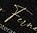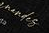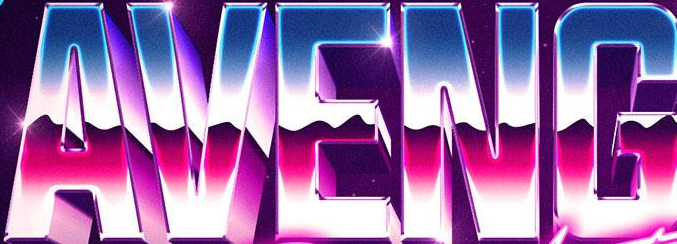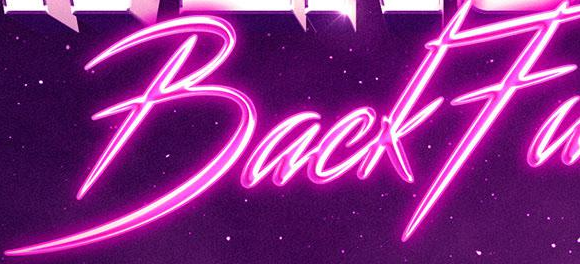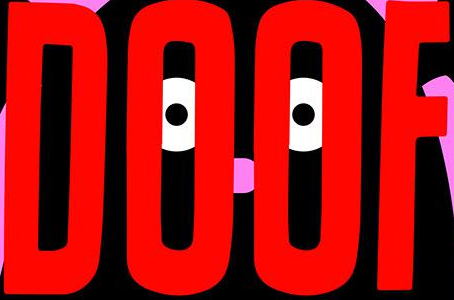Read the text from these images in sequence, separated by a semicolon. Fu; #####; AVENG; BackFa; DOOF 